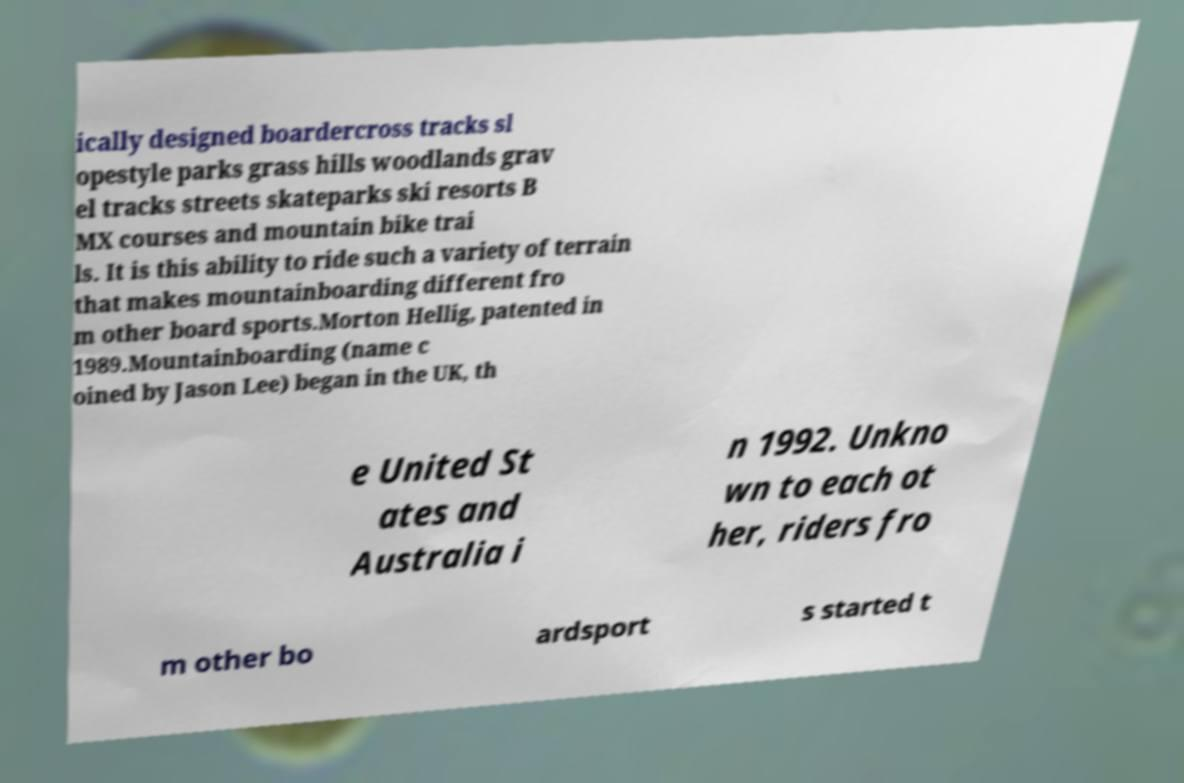I need the written content from this picture converted into text. Can you do that? ically designed boardercross tracks sl opestyle parks grass hills woodlands grav el tracks streets skateparks ski resorts B MX courses and mountain bike trai ls. It is this ability to ride such a variety of terrain that makes mountainboarding different fro m other board sports.Morton Hellig, patented in 1989.Mountainboarding (name c oined by Jason Lee) began in the UK, th e United St ates and Australia i n 1992. Unkno wn to each ot her, riders fro m other bo ardsport s started t 